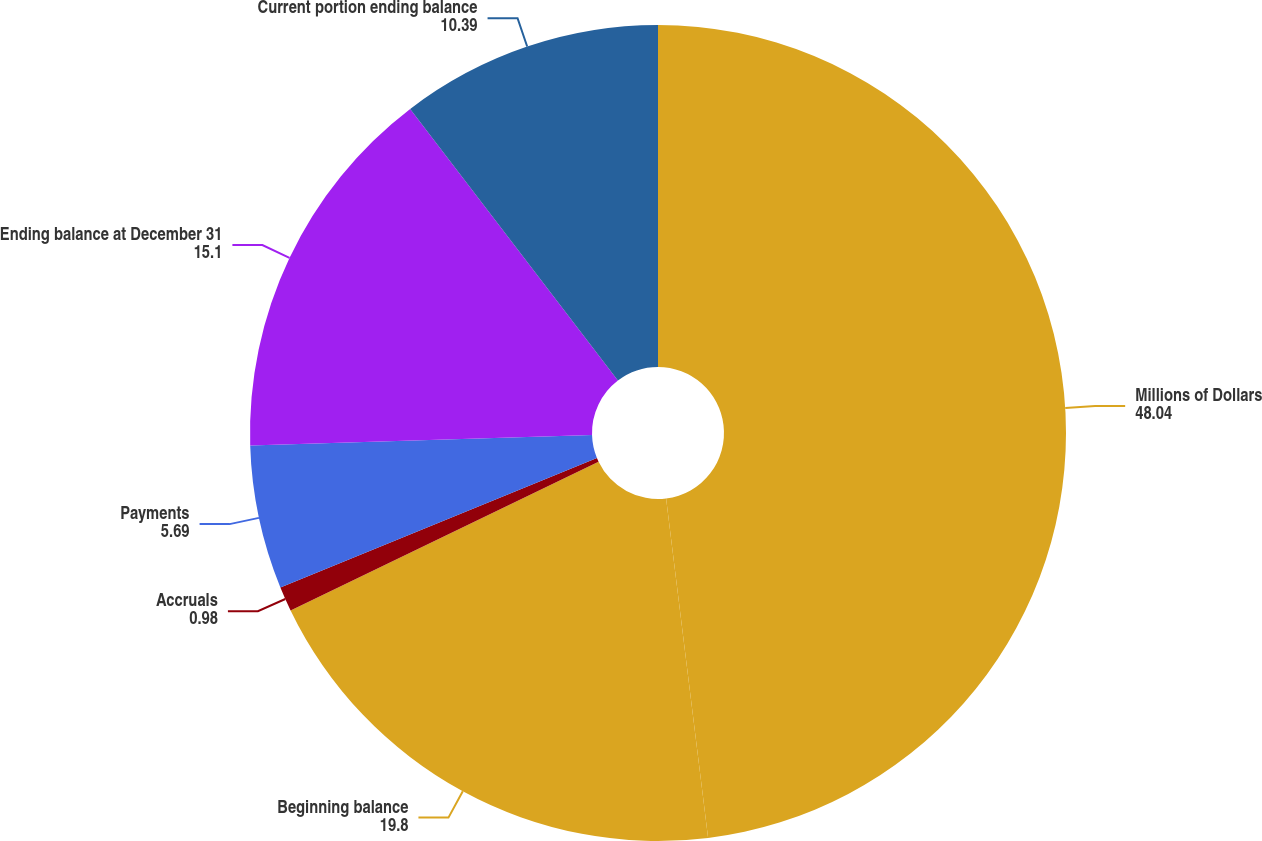Convert chart to OTSL. <chart><loc_0><loc_0><loc_500><loc_500><pie_chart><fcel>Millions of Dollars<fcel>Beginning balance<fcel>Accruals<fcel>Payments<fcel>Ending balance at December 31<fcel>Current portion ending balance<nl><fcel>48.04%<fcel>19.8%<fcel>0.98%<fcel>5.69%<fcel>15.1%<fcel>10.39%<nl></chart> 